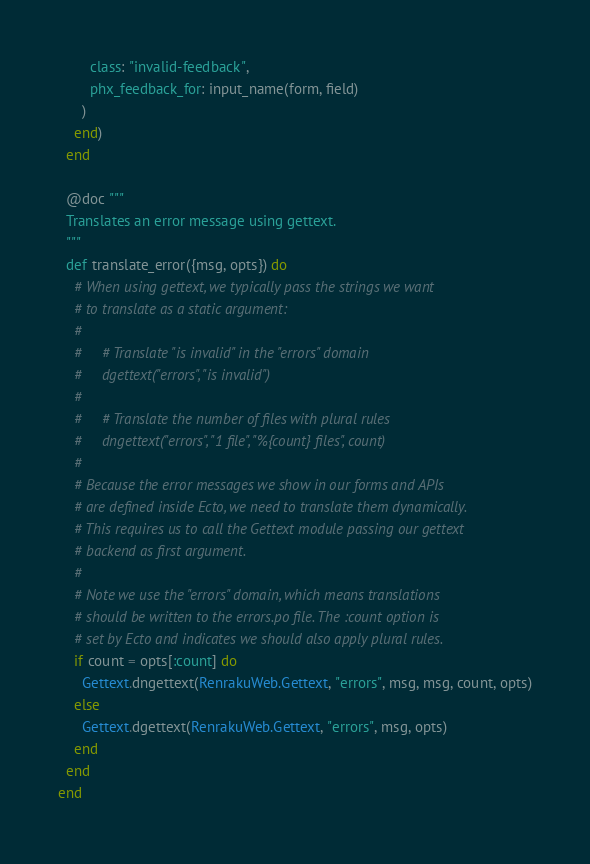<code> <loc_0><loc_0><loc_500><loc_500><_Elixir_>        class: "invalid-feedback",
        phx_feedback_for: input_name(form, field)
      )
    end)
  end

  @doc """
  Translates an error message using gettext.
  """
  def translate_error({msg, opts}) do
    # When using gettext, we typically pass the strings we want
    # to translate as a static argument:
    #
    #     # Translate "is invalid" in the "errors" domain
    #     dgettext("errors", "is invalid")
    #
    #     # Translate the number of files with plural rules
    #     dngettext("errors", "1 file", "%{count} files", count)
    #
    # Because the error messages we show in our forms and APIs
    # are defined inside Ecto, we need to translate them dynamically.
    # This requires us to call the Gettext module passing our gettext
    # backend as first argument.
    #
    # Note we use the "errors" domain, which means translations
    # should be written to the errors.po file. The :count option is
    # set by Ecto and indicates we should also apply plural rules.
    if count = opts[:count] do
      Gettext.dngettext(RenrakuWeb.Gettext, "errors", msg, msg, count, opts)
    else
      Gettext.dgettext(RenrakuWeb.Gettext, "errors", msg, opts)
    end
  end
end
</code> 